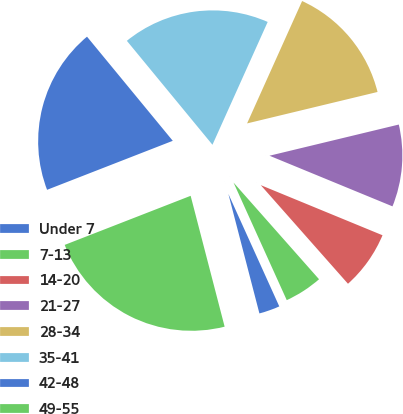<chart> <loc_0><loc_0><loc_500><loc_500><pie_chart><fcel>Under 7<fcel>7-13<fcel>14-20<fcel>21-27<fcel>28-34<fcel>35-41<fcel>42-48<fcel>49-55<nl><fcel>2.72%<fcel>4.76%<fcel>7.26%<fcel>9.98%<fcel>14.51%<fcel>17.69%<fcel>19.95%<fcel>23.13%<nl></chart> 